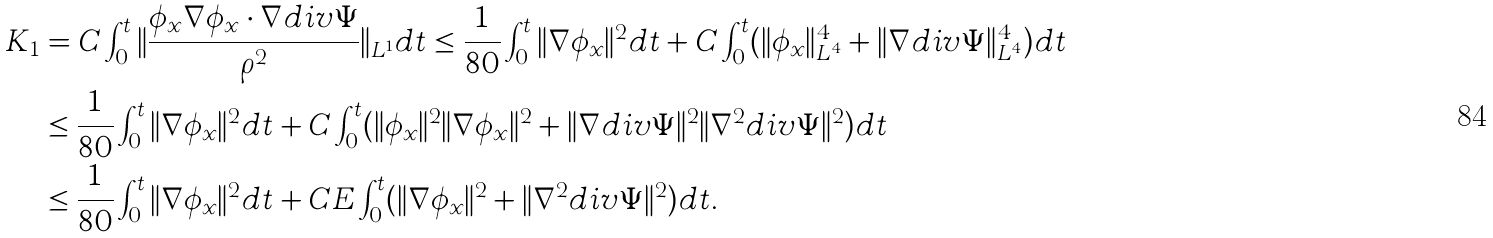<formula> <loc_0><loc_0><loc_500><loc_500>K _ { 1 } & = C \int _ { 0 } ^ { t } \| \frac { \phi _ { x } \nabla \phi _ { x } \cdot \nabla d i v \Psi } { \rho ^ { 2 } } \| _ { L ^ { 1 } } d t \leq \frac { 1 } { 8 0 } \int _ { 0 } ^ { t } \| \nabla \phi _ { x } \| ^ { 2 } d t + C \int _ { 0 } ^ { t } ( \| \phi _ { x } \| _ { L ^ { 4 } } ^ { 4 } + \| \nabla d i v \Psi \| _ { L ^ { 4 } } ^ { 4 } ) d t \\ & \leq \frac { 1 } { 8 0 } \int _ { 0 } ^ { t } \| \nabla \phi _ { x } \| ^ { 2 } d t + C \int _ { 0 } ^ { t } ( \| \phi _ { x } \| ^ { 2 } \| \nabla \phi _ { x } \| ^ { 2 } + \| \nabla d i v \Psi \| ^ { 2 } \| \nabla ^ { 2 } d i v \Psi \| ^ { 2 } ) d t \\ & \leq \frac { 1 } { 8 0 } \int _ { 0 } ^ { t } \| \nabla \phi _ { x } \| ^ { 2 } d t + C E \int _ { 0 } ^ { t } ( \| \nabla \phi _ { x } \| ^ { 2 } + \| \nabla ^ { 2 } d i v \Psi \| ^ { 2 } ) d t .</formula> 